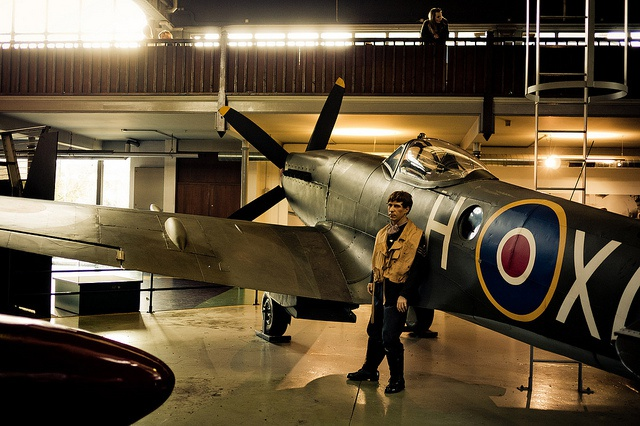Describe the objects in this image and their specific colors. I can see airplane in white, black, maroon, olive, and tan tones, airplane in white, black, maroon, and gray tones, and people in white, black, olive, and maroon tones in this image. 